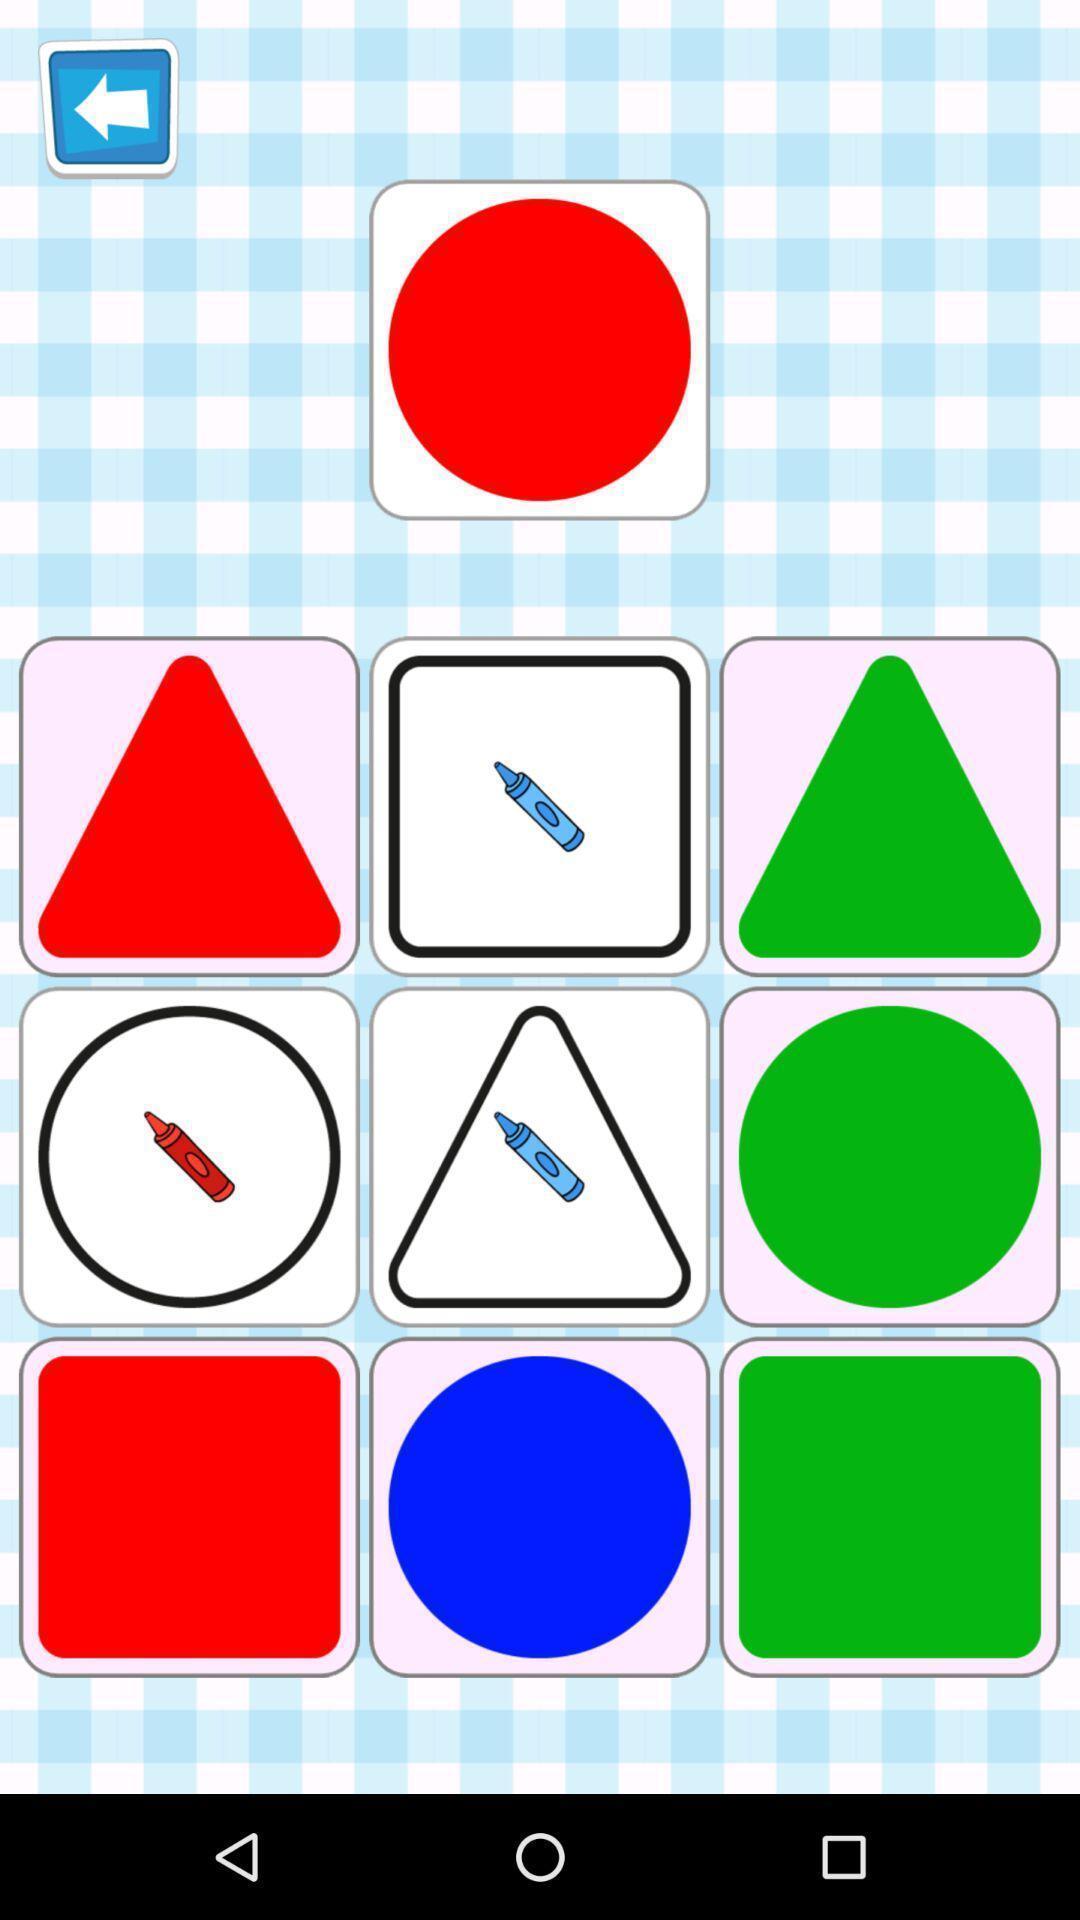Give me a narrative description of this picture. Page displaying various shapes and colors. 